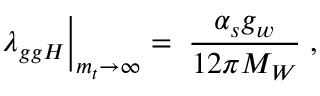<formula> <loc_0><loc_0><loc_500><loc_500>\lambda _ { g g H } \Big | _ { m _ { t } \to \infty } \, = \, \frac { \alpha _ { s } g _ { w } } { 1 2 \pi M _ { W } } \, ,</formula> 